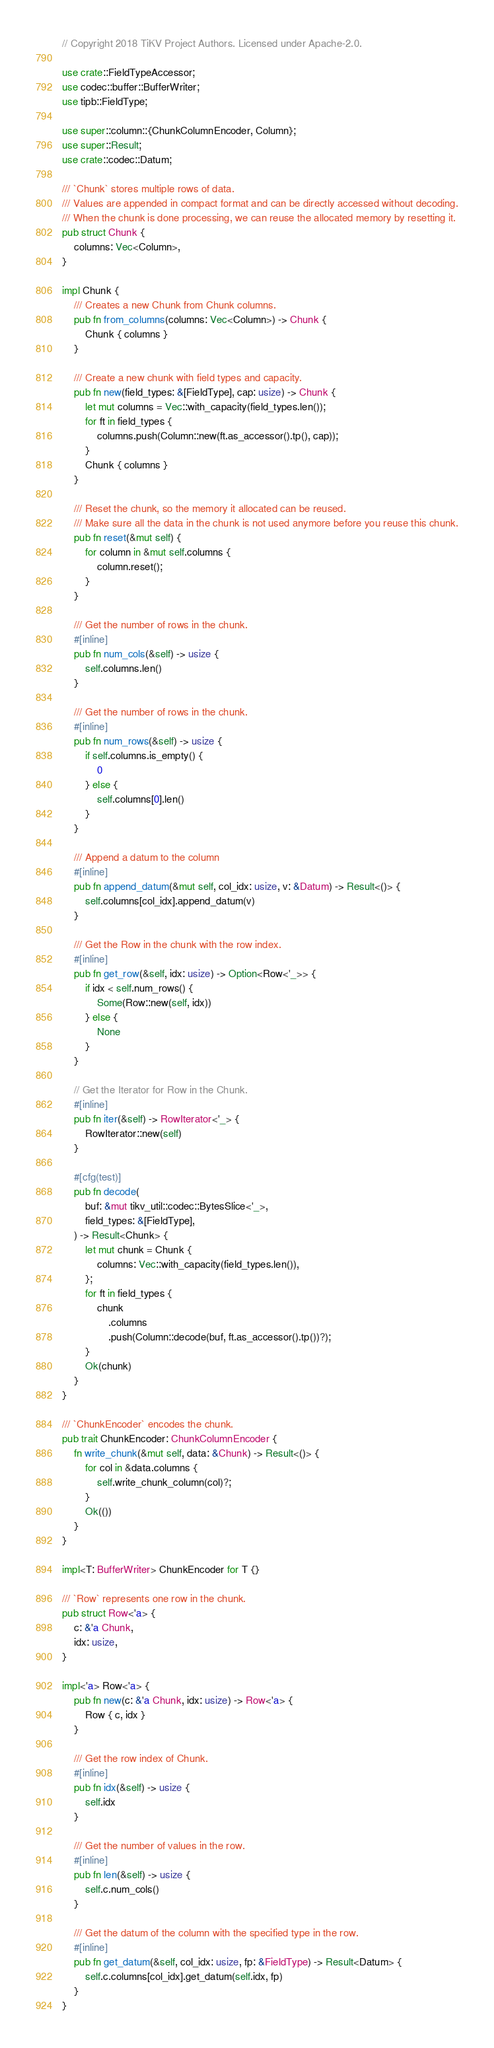<code> <loc_0><loc_0><loc_500><loc_500><_Rust_>// Copyright 2018 TiKV Project Authors. Licensed under Apache-2.0.

use crate::FieldTypeAccessor;
use codec::buffer::BufferWriter;
use tipb::FieldType;

use super::column::{ChunkColumnEncoder, Column};
use super::Result;
use crate::codec::Datum;

/// `Chunk` stores multiple rows of data.
/// Values are appended in compact format and can be directly accessed without decoding.
/// When the chunk is done processing, we can reuse the allocated memory by resetting it.
pub struct Chunk {
    columns: Vec<Column>,
}

impl Chunk {
    /// Creates a new Chunk from Chunk columns.
    pub fn from_columns(columns: Vec<Column>) -> Chunk {
        Chunk { columns }
    }

    /// Create a new chunk with field types and capacity.
    pub fn new(field_types: &[FieldType], cap: usize) -> Chunk {
        let mut columns = Vec::with_capacity(field_types.len());
        for ft in field_types {
            columns.push(Column::new(ft.as_accessor().tp(), cap));
        }
        Chunk { columns }
    }

    /// Reset the chunk, so the memory it allocated can be reused.
    /// Make sure all the data in the chunk is not used anymore before you reuse this chunk.
    pub fn reset(&mut self) {
        for column in &mut self.columns {
            column.reset();
        }
    }

    /// Get the number of rows in the chunk.
    #[inline]
    pub fn num_cols(&self) -> usize {
        self.columns.len()
    }

    /// Get the number of rows in the chunk.
    #[inline]
    pub fn num_rows(&self) -> usize {
        if self.columns.is_empty() {
            0
        } else {
            self.columns[0].len()
        }
    }

    /// Append a datum to the column
    #[inline]
    pub fn append_datum(&mut self, col_idx: usize, v: &Datum) -> Result<()> {
        self.columns[col_idx].append_datum(v)
    }

    /// Get the Row in the chunk with the row index.
    #[inline]
    pub fn get_row(&self, idx: usize) -> Option<Row<'_>> {
        if idx < self.num_rows() {
            Some(Row::new(self, idx))
        } else {
            None
        }
    }

    // Get the Iterator for Row in the Chunk.
    #[inline]
    pub fn iter(&self) -> RowIterator<'_> {
        RowIterator::new(self)
    }

    #[cfg(test)]
    pub fn decode(
        buf: &mut tikv_util::codec::BytesSlice<'_>,
        field_types: &[FieldType],
    ) -> Result<Chunk> {
        let mut chunk = Chunk {
            columns: Vec::with_capacity(field_types.len()),
        };
        for ft in field_types {
            chunk
                .columns
                .push(Column::decode(buf, ft.as_accessor().tp())?);
        }
        Ok(chunk)
    }
}

/// `ChunkEncoder` encodes the chunk.
pub trait ChunkEncoder: ChunkColumnEncoder {
    fn write_chunk(&mut self, data: &Chunk) -> Result<()> {
        for col in &data.columns {
            self.write_chunk_column(col)?;
        }
        Ok(())
    }
}

impl<T: BufferWriter> ChunkEncoder for T {}

/// `Row` represents one row in the chunk.
pub struct Row<'a> {
    c: &'a Chunk,
    idx: usize,
}

impl<'a> Row<'a> {
    pub fn new(c: &'a Chunk, idx: usize) -> Row<'a> {
        Row { c, idx }
    }

    /// Get the row index of Chunk.
    #[inline]
    pub fn idx(&self) -> usize {
        self.idx
    }

    /// Get the number of values in the row.
    #[inline]
    pub fn len(&self) -> usize {
        self.c.num_cols()
    }

    /// Get the datum of the column with the specified type in the row.
    #[inline]
    pub fn get_datum(&self, col_idx: usize, fp: &FieldType) -> Result<Datum> {
        self.c.columns[col_idx].get_datum(self.idx, fp)
    }
}
</code> 